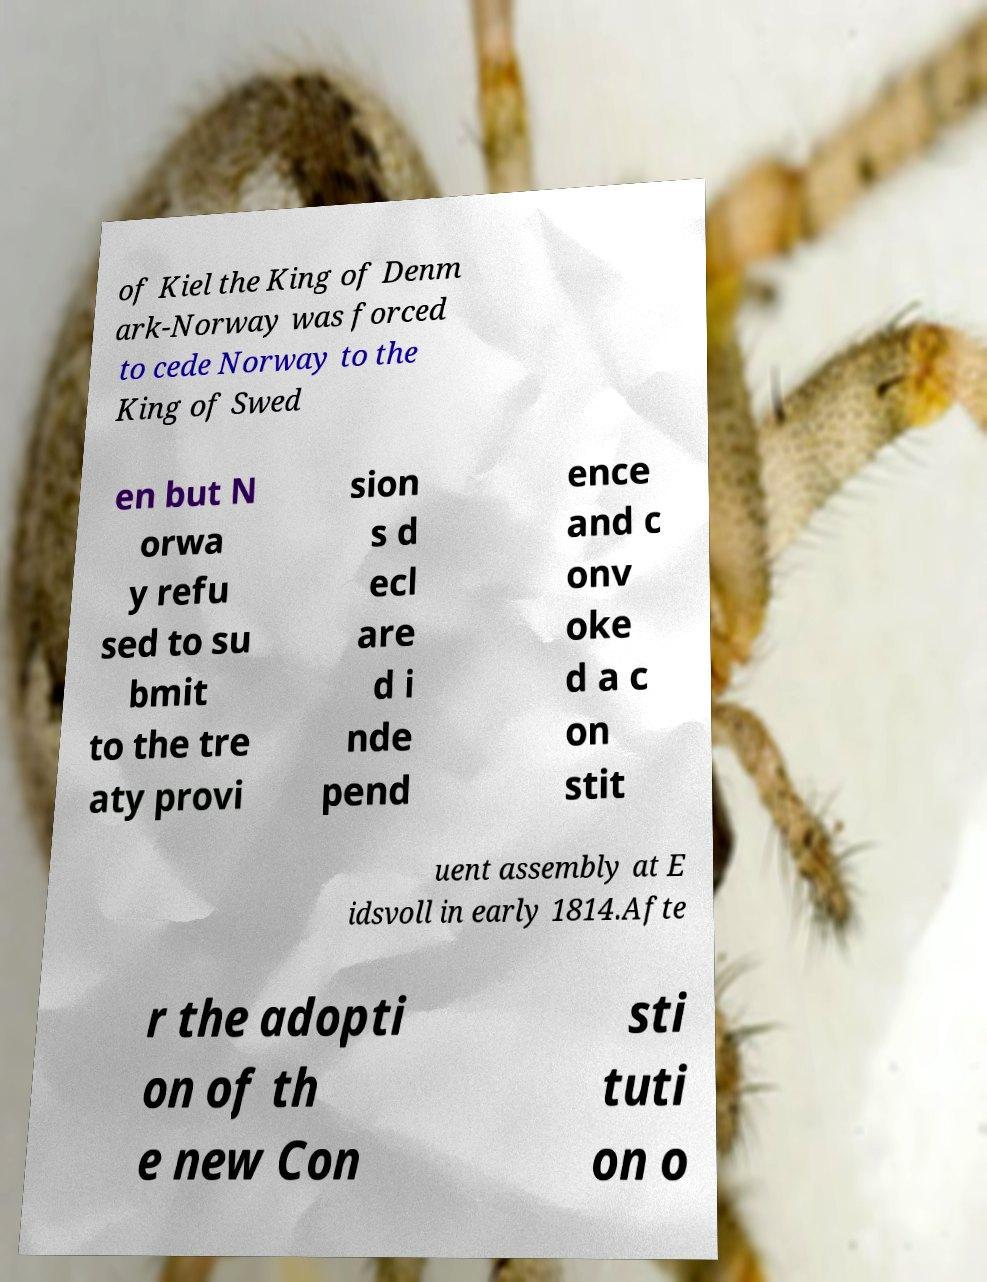Could you extract and type out the text from this image? of Kiel the King of Denm ark-Norway was forced to cede Norway to the King of Swed en but N orwa y refu sed to su bmit to the tre aty provi sion s d ecl are d i nde pend ence and c onv oke d a c on stit uent assembly at E idsvoll in early 1814.Afte r the adopti on of th e new Con sti tuti on o 